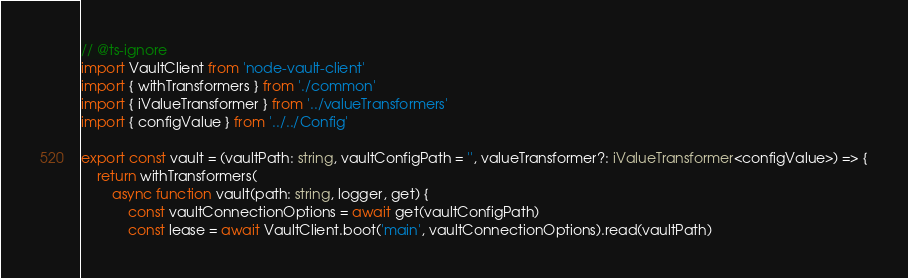<code> <loc_0><loc_0><loc_500><loc_500><_TypeScript_>// @ts-ignore
import VaultClient from 'node-vault-client'
import { withTransformers } from './common'
import { iValueTransformer } from '../valueTransformers'
import { configValue } from '../../Config'

export const vault = (vaultPath: string, vaultConfigPath = '', valueTransformer?: iValueTransformer<configValue>) => {
    return withTransformers(
        async function vault(path: string, logger, get) {
            const vaultConnectionOptions = await get(vaultConfigPath)
            const lease = await VaultClient.boot('main', vaultConnectionOptions).read(vaultPath)</code> 